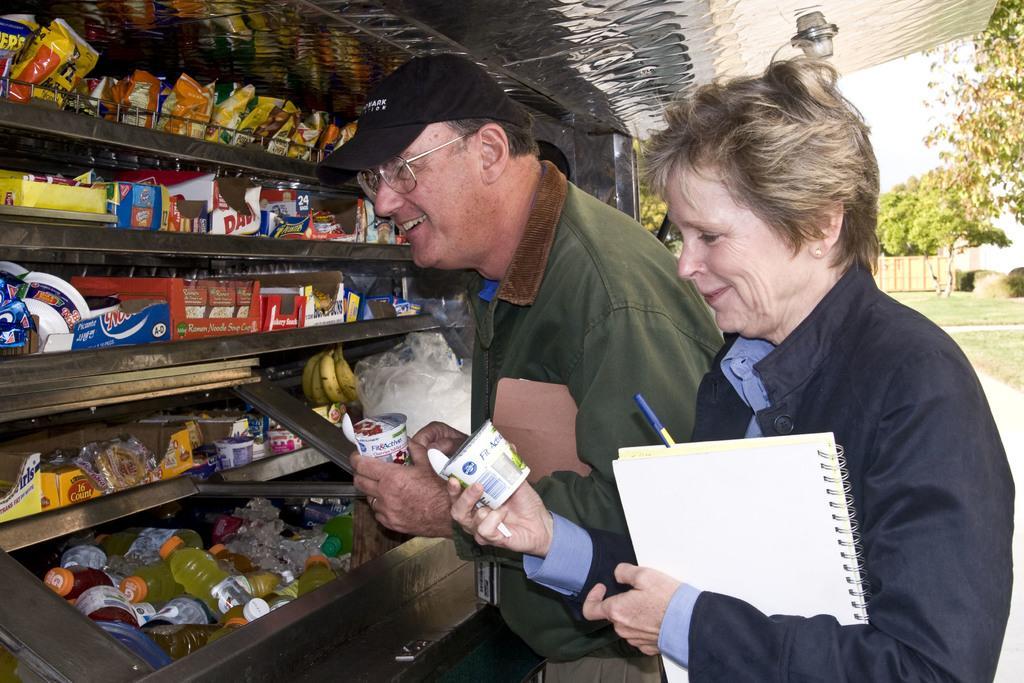How would you summarize this image in a sentence or two? In this image, we can see a man and woman are holding some containers, spoons and objects. They are smiling. A man is wearing a cap and glasses. Here we can see iron rack. So many objects and things are placed on the racks. Top of the image, we can see iron sheet. Background there are so many trees, grass, plants and wall. 